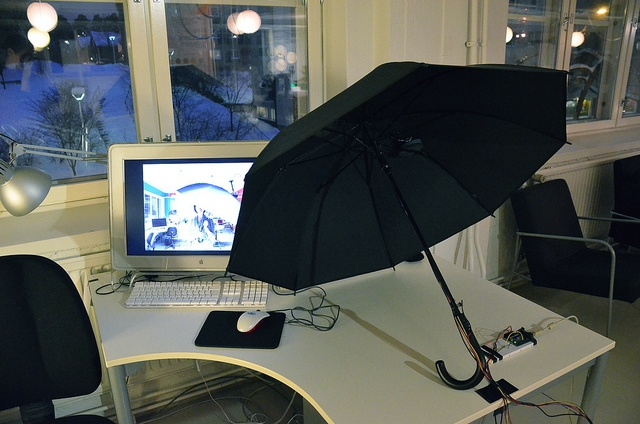Describe the objects in this image and their specific colors. I can see umbrella in black, gray, and darkgray tones, tv in black, white, navy, gray, and tan tones, chair in black and gray tones, chair in black, gray, and darkgreen tones, and keyboard in black, darkgray, gray, and tan tones in this image. 